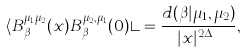Convert formula to latex. <formula><loc_0><loc_0><loc_500><loc_500>\langle B _ { \beta } ^ { \mu _ { 1 } \mu _ { 2 } } ( x ) B _ { \beta } ^ { \mu _ { 2 } , \mu _ { 1 } } ( 0 ) \rangle = \frac { d ( \beta | \mu _ { 1 } , \mu _ { 2 } ) } { | x | ^ { 2 \Delta _ { \beta } } } ,</formula> 